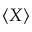<formula> <loc_0><loc_0><loc_500><loc_500>\langle X \rangle</formula> 